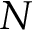<formula> <loc_0><loc_0><loc_500><loc_500>N</formula> 